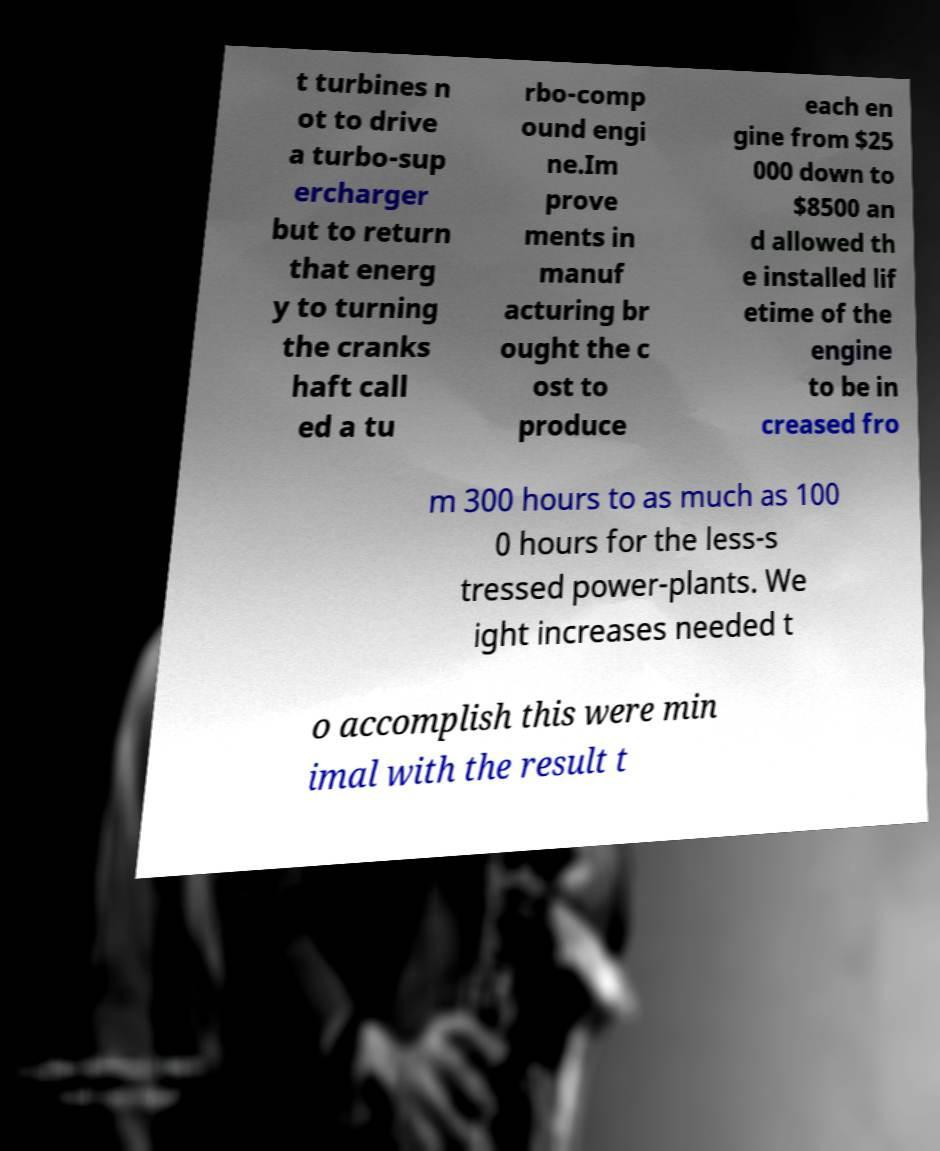Can you read and provide the text displayed in the image?This photo seems to have some interesting text. Can you extract and type it out for me? t turbines n ot to drive a turbo-sup ercharger but to return that energ y to turning the cranks haft call ed a tu rbo-comp ound engi ne.Im prove ments in manuf acturing br ought the c ost to produce each en gine from $25 000 down to $8500 an d allowed th e installed lif etime of the engine to be in creased fro m 300 hours to as much as 100 0 hours for the less-s tressed power-plants. We ight increases needed t o accomplish this were min imal with the result t 